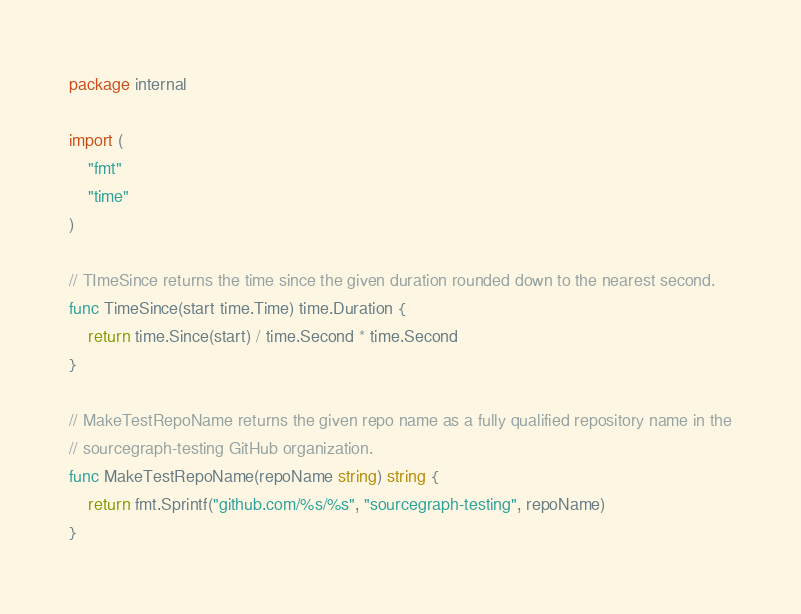Convert code to text. <code><loc_0><loc_0><loc_500><loc_500><_Go_>package internal

import (
	"fmt"
	"time"
)

// TImeSince returns the time since the given duration rounded down to the nearest second.
func TimeSince(start time.Time) time.Duration {
	return time.Since(start) / time.Second * time.Second
}

// MakeTestRepoName returns the given repo name as a fully qualified repository name in the
// sourcegraph-testing GitHub organization.
func MakeTestRepoName(repoName string) string {
	return fmt.Sprintf("github.com/%s/%s", "sourcegraph-testing", repoName)
}
</code> 